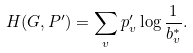<formula> <loc_0><loc_0><loc_500><loc_500>H ( G , P ^ { \prime } ) = \sum _ { v } p ^ { \prime } _ { v } \log \frac { 1 } { b ^ { * } _ { v } } .</formula> 